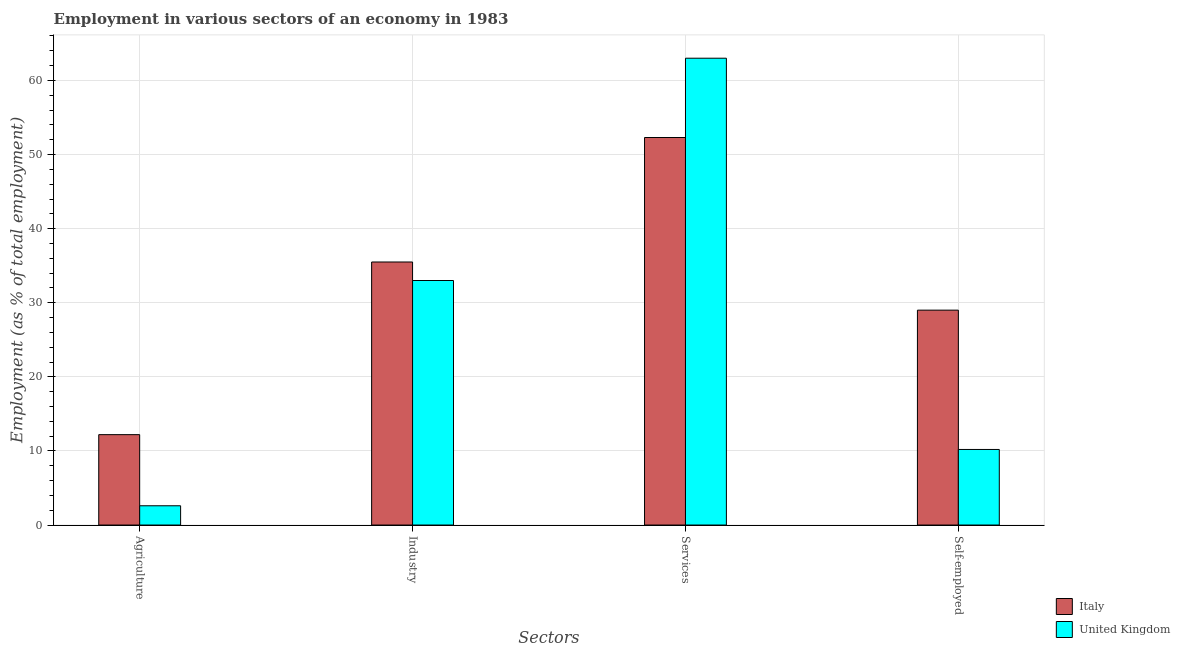How many groups of bars are there?
Make the answer very short. 4. Are the number of bars per tick equal to the number of legend labels?
Your answer should be very brief. Yes. Are the number of bars on each tick of the X-axis equal?
Keep it short and to the point. Yes. How many bars are there on the 1st tick from the left?
Your response must be concise. 2. How many bars are there on the 1st tick from the right?
Ensure brevity in your answer.  2. What is the label of the 4th group of bars from the left?
Your response must be concise. Self-employed. What is the percentage of workers in agriculture in Italy?
Give a very brief answer. 12.2. Across all countries, what is the maximum percentage of workers in industry?
Your answer should be very brief. 35.5. Across all countries, what is the minimum percentage of self employed workers?
Offer a very short reply. 10.2. In which country was the percentage of workers in agriculture maximum?
Your answer should be very brief. Italy. In which country was the percentage of workers in industry minimum?
Keep it short and to the point. United Kingdom. What is the total percentage of self employed workers in the graph?
Keep it short and to the point. 39.2. What is the difference between the percentage of workers in agriculture in United Kingdom and that in Italy?
Give a very brief answer. -9.6. What is the difference between the percentage of workers in agriculture in United Kingdom and the percentage of workers in services in Italy?
Make the answer very short. -49.7. What is the average percentage of workers in agriculture per country?
Provide a succinct answer. 7.4. What is the difference between the percentage of workers in agriculture and percentage of workers in industry in United Kingdom?
Ensure brevity in your answer.  -30.4. In how many countries, is the percentage of workers in services greater than 8 %?
Provide a succinct answer. 2. What is the ratio of the percentage of self employed workers in United Kingdom to that in Italy?
Offer a very short reply. 0.35. What is the difference between the highest and the second highest percentage of workers in services?
Offer a terse response. 10.7. What is the difference between the highest and the lowest percentage of workers in agriculture?
Give a very brief answer. 9.6. Is it the case that in every country, the sum of the percentage of workers in services and percentage of self employed workers is greater than the sum of percentage of workers in agriculture and percentage of workers in industry?
Offer a terse response. No. What does the 2nd bar from the left in Services represents?
Ensure brevity in your answer.  United Kingdom. What does the 2nd bar from the right in Agriculture represents?
Offer a very short reply. Italy. How many bars are there?
Offer a very short reply. 8. How many countries are there in the graph?
Your response must be concise. 2. What is the difference between two consecutive major ticks on the Y-axis?
Your response must be concise. 10. What is the title of the graph?
Offer a very short reply. Employment in various sectors of an economy in 1983. Does "Armenia" appear as one of the legend labels in the graph?
Make the answer very short. No. What is the label or title of the X-axis?
Provide a short and direct response. Sectors. What is the label or title of the Y-axis?
Make the answer very short. Employment (as % of total employment). What is the Employment (as % of total employment) in Italy in Agriculture?
Offer a very short reply. 12.2. What is the Employment (as % of total employment) of United Kingdom in Agriculture?
Keep it short and to the point. 2.6. What is the Employment (as % of total employment) of Italy in Industry?
Keep it short and to the point. 35.5. What is the Employment (as % of total employment) in United Kingdom in Industry?
Offer a terse response. 33. What is the Employment (as % of total employment) in Italy in Services?
Offer a very short reply. 52.3. What is the Employment (as % of total employment) of United Kingdom in Self-employed?
Offer a terse response. 10.2. Across all Sectors, what is the maximum Employment (as % of total employment) in Italy?
Make the answer very short. 52.3. Across all Sectors, what is the maximum Employment (as % of total employment) in United Kingdom?
Your response must be concise. 63. Across all Sectors, what is the minimum Employment (as % of total employment) of Italy?
Make the answer very short. 12.2. Across all Sectors, what is the minimum Employment (as % of total employment) of United Kingdom?
Keep it short and to the point. 2.6. What is the total Employment (as % of total employment) in Italy in the graph?
Your answer should be very brief. 129. What is the total Employment (as % of total employment) in United Kingdom in the graph?
Provide a short and direct response. 108.8. What is the difference between the Employment (as % of total employment) of Italy in Agriculture and that in Industry?
Offer a terse response. -23.3. What is the difference between the Employment (as % of total employment) in United Kingdom in Agriculture and that in Industry?
Your answer should be compact. -30.4. What is the difference between the Employment (as % of total employment) of Italy in Agriculture and that in Services?
Provide a short and direct response. -40.1. What is the difference between the Employment (as % of total employment) in United Kingdom in Agriculture and that in Services?
Provide a short and direct response. -60.4. What is the difference between the Employment (as % of total employment) in Italy in Agriculture and that in Self-employed?
Provide a short and direct response. -16.8. What is the difference between the Employment (as % of total employment) of Italy in Industry and that in Services?
Keep it short and to the point. -16.8. What is the difference between the Employment (as % of total employment) in United Kingdom in Industry and that in Services?
Your answer should be very brief. -30. What is the difference between the Employment (as % of total employment) in Italy in Industry and that in Self-employed?
Your answer should be compact. 6.5. What is the difference between the Employment (as % of total employment) in United Kingdom in Industry and that in Self-employed?
Your answer should be compact. 22.8. What is the difference between the Employment (as % of total employment) of Italy in Services and that in Self-employed?
Ensure brevity in your answer.  23.3. What is the difference between the Employment (as % of total employment) of United Kingdom in Services and that in Self-employed?
Your response must be concise. 52.8. What is the difference between the Employment (as % of total employment) in Italy in Agriculture and the Employment (as % of total employment) in United Kingdom in Industry?
Ensure brevity in your answer.  -20.8. What is the difference between the Employment (as % of total employment) of Italy in Agriculture and the Employment (as % of total employment) of United Kingdom in Services?
Your answer should be very brief. -50.8. What is the difference between the Employment (as % of total employment) in Italy in Industry and the Employment (as % of total employment) in United Kingdom in Services?
Offer a very short reply. -27.5. What is the difference between the Employment (as % of total employment) in Italy in Industry and the Employment (as % of total employment) in United Kingdom in Self-employed?
Your response must be concise. 25.3. What is the difference between the Employment (as % of total employment) in Italy in Services and the Employment (as % of total employment) in United Kingdom in Self-employed?
Provide a short and direct response. 42.1. What is the average Employment (as % of total employment) in Italy per Sectors?
Provide a succinct answer. 32.25. What is the average Employment (as % of total employment) of United Kingdom per Sectors?
Your response must be concise. 27.2. What is the difference between the Employment (as % of total employment) of Italy and Employment (as % of total employment) of United Kingdom in Industry?
Offer a terse response. 2.5. What is the difference between the Employment (as % of total employment) in Italy and Employment (as % of total employment) in United Kingdom in Services?
Your answer should be compact. -10.7. What is the ratio of the Employment (as % of total employment) of Italy in Agriculture to that in Industry?
Your answer should be compact. 0.34. What is the ratio of the Employment (as % of total employment) in United Kingdom in Agriculture to that in Industry?
Provide a succinct answer. 0.08. What is the ratio of the Employment (as % of total employment) in Italy in Agriculture to that in Services?
Offer a terse response. 0.23. What is the ratio of the Employment (as % of total employment) of United Kingdom in Agriculture to that in Services?
Provide a succinct answer. 0.04. What is the ratio of the Employment (as % of total employment) in Italy in Agriculture to that in Self-employed?
Your answer should be compact. 0.42. What is the ratio of the Employment (as % of total employment) in United Kingdom in Agriculture to that in Self-employed?
Make the answer very short. 0.25. What is the ratio of the Employment (as % of total employment) of Italy in Industry to that in Services?
Offer a very short reply. 0.68. What is the ratio of the Employment (as % of total employment) of United Kingdom in Industry to that in Services?
Make the answer very short. 0.52. What is the ratio of the Employment (as % of total employment) in Italy in Industry to that in Self-employed?
Make the answer very short. 1.22. What is the ratio of the Employment (as % of total employment) of United Kingdom in Industry to that in Self-employed?
Your answer should be very brief. 3.24. What is the ratio of the Employment (as % of total employment) of Italy in Services to that in Self-employed?
Your response must be concise. 1.8. What is the ratio of the Employment (as % of total employment) of United Kingdom in Services to that in Self-employed?
Provide a short and direct response. 6.18. What is the difference between the highest and the second highest Employment (as % of total employment) in Italy?
Keep it short and to the point. 16.8. What is the difference between the highest and the second highest Employment (as % of total employment) in United Kingdom?
Provide a succinct answer. 30. What is the difference between the highest and the lowest Employment (as % of total employment) in Italy?
Give a very brief answer. 40.1. What is the difference between the highest and the lowest Employment (as % of total employment) in United Kingdom?
Keep it short and to the point. 60.4. 